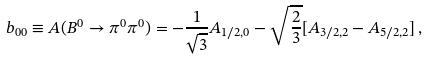<formula> <loc_0><loc_0><loc_500><loc_500>b _ { 0 0 } \equiv A ( B ^ { 0 } \to \pi ^ { 0 } \pi ^ { 0 } ) = - \frac { 1 } { \sqrt { 3 } } A _ { 1 / 2 , 0 } - \sqrt { \frac { 2 } { 3 } } [ A _ { 3 / 2 , 2 } - A _ { 5 / 2 , 2 } ] \, ,</formula> 